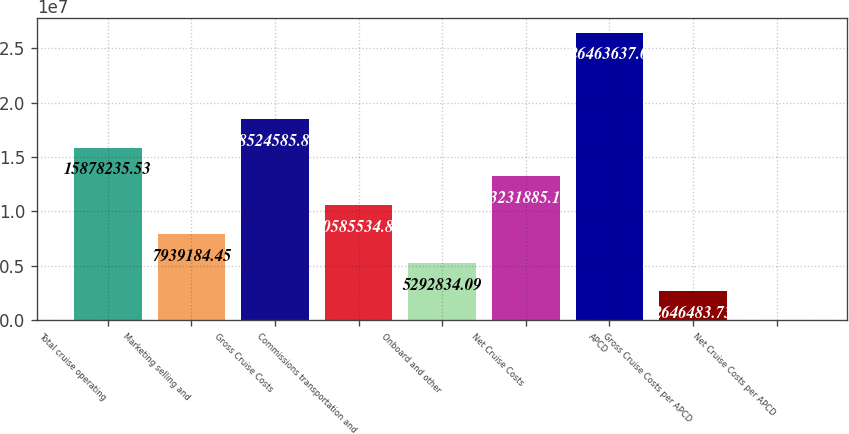Convert chart. <chart><loc_0><loc_0><loc_500><loc_500><bar_chart><fcel>Total cruise operating<fcel>Marketing selling and<fcel>Gross Cruise Costs<fcel>Commissions transportation and<fcel>Onboard and other<fcel>Net Cruise Costs<fcel>APCD<fcel>Gross Cruise Costs per APCD<fcel>Net Cruise Costs per APCD<nl><fcel>1.58782e+07<fcel>7.93918e+06<fcel>1.85246e+07<fcel>1.05855e+07<fcel>5.29283e+06<fcel>1.32319e+07<fcel>2.64636e+07<fcel>2.64648e+06<fcel>133.37<nl></chart> 